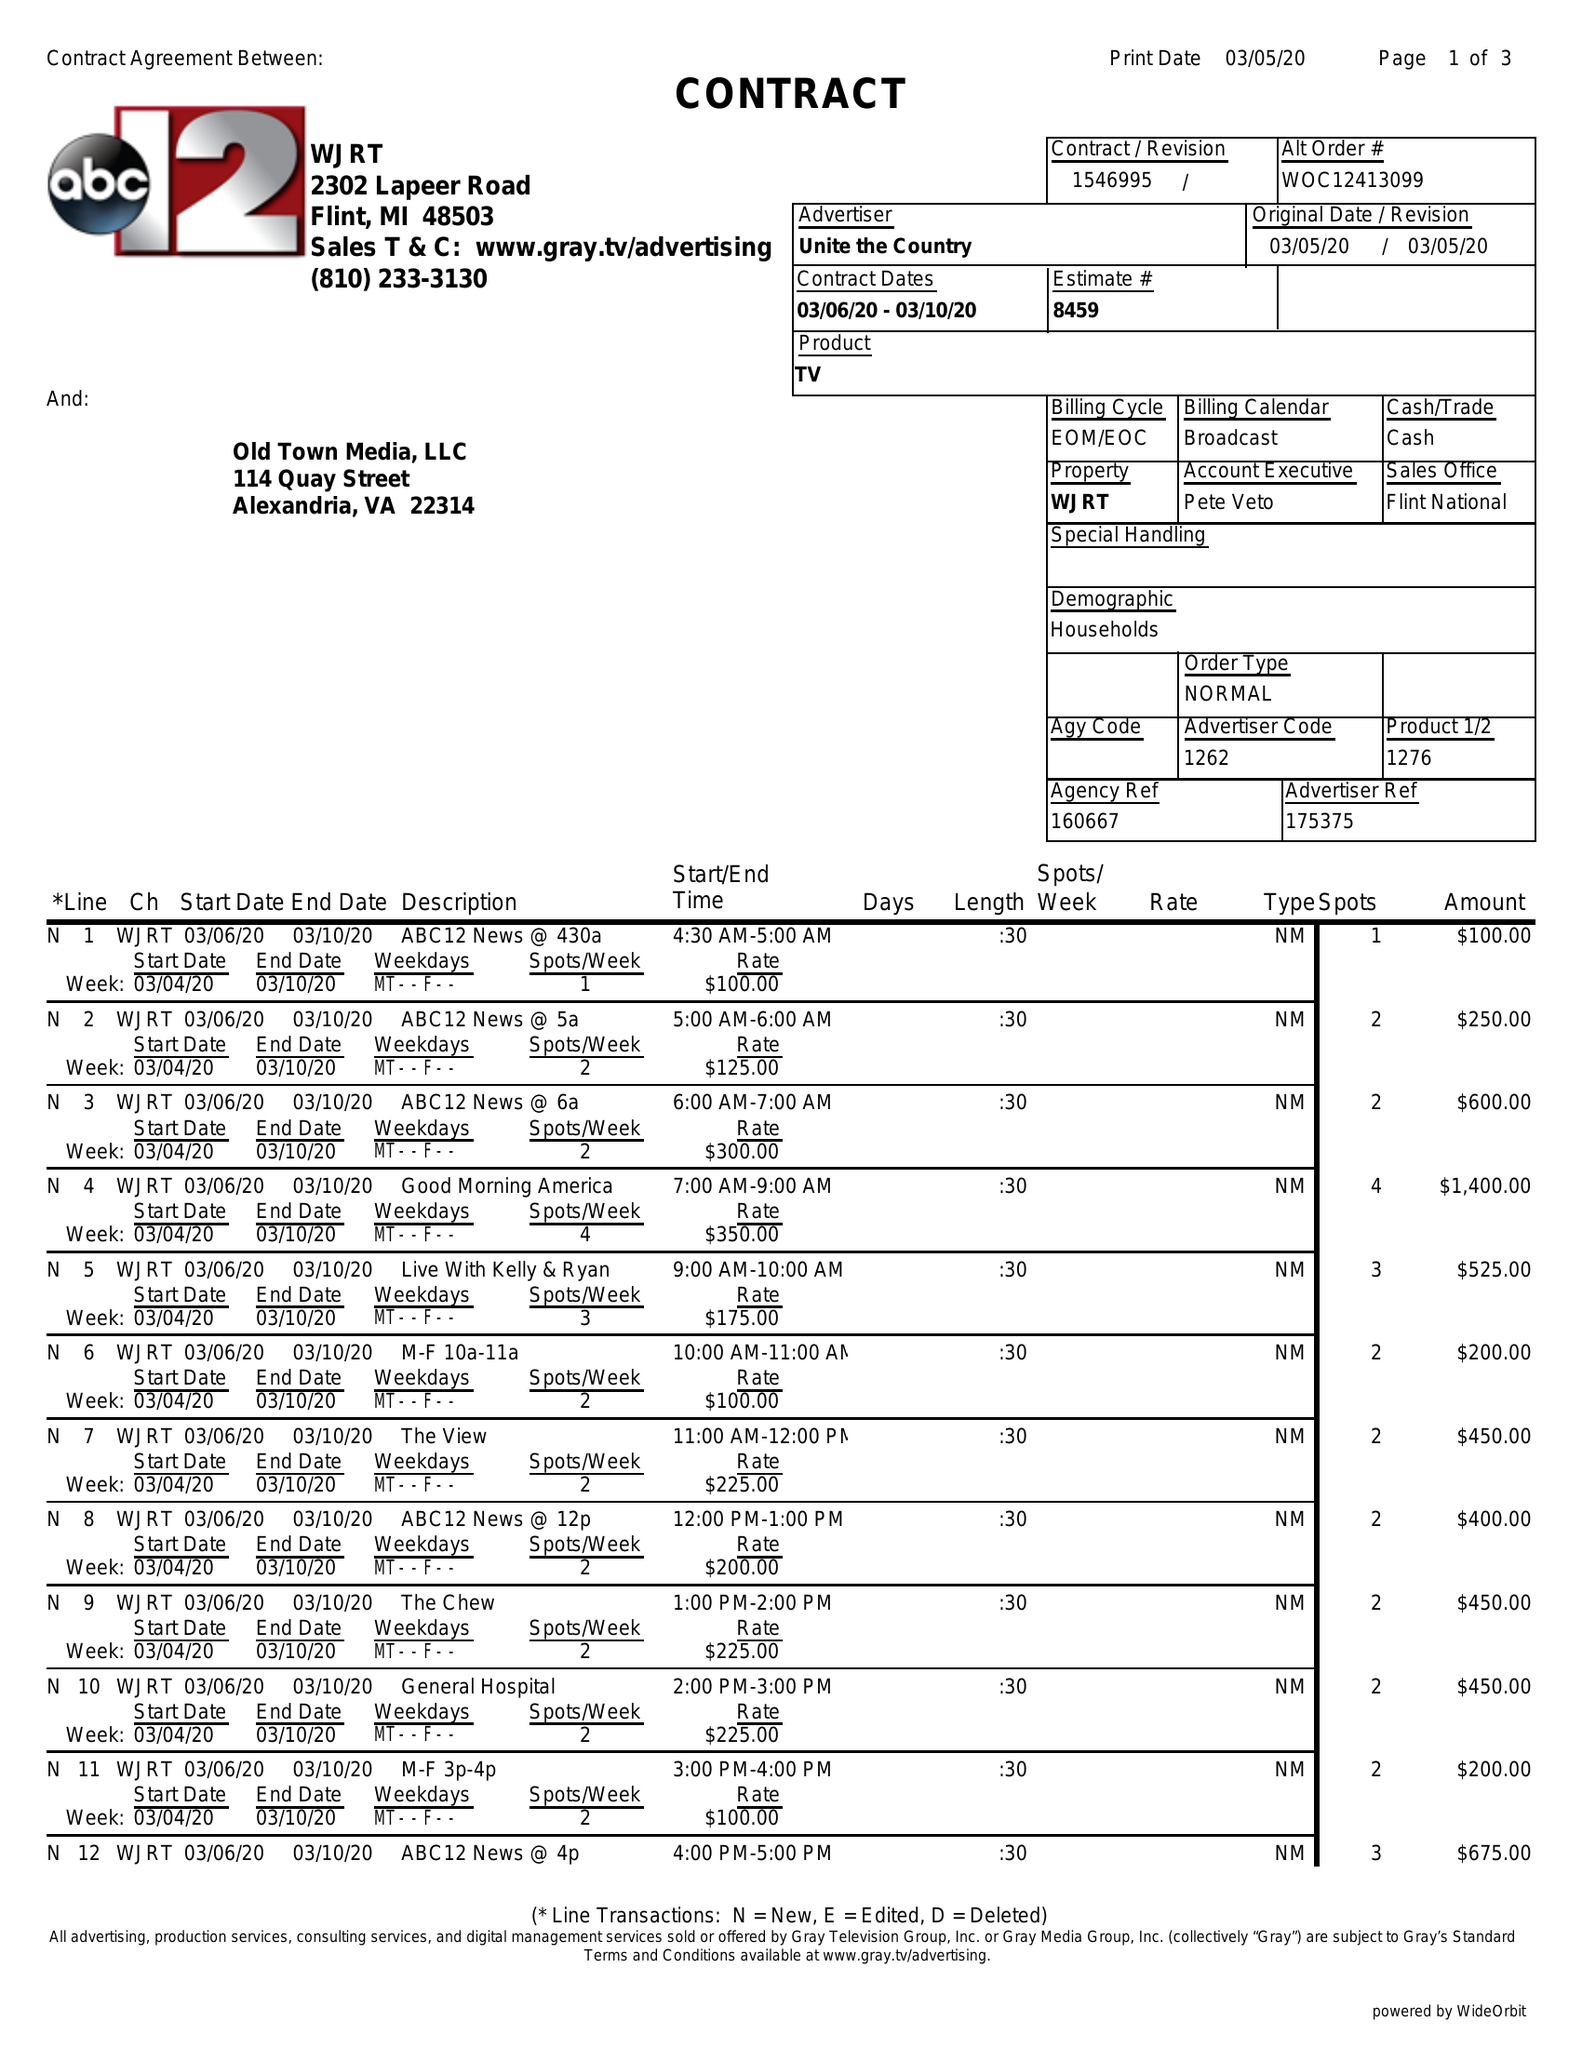What is the value for the flight_from?
Answer the question using a single word or phrase. 03/06/20 